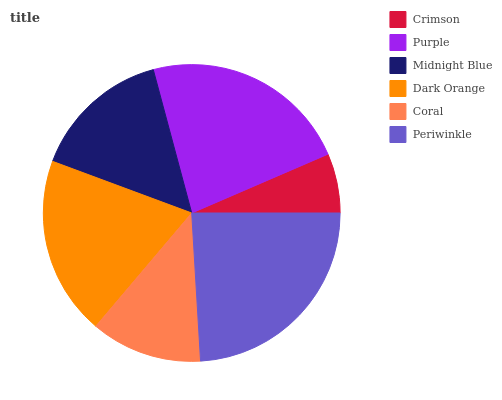Is Crimson the minimum?
Answer yes or no. Yes. Is Periwinkle the maximum?
Answer yes or no. Yes. Is Purple the minimum?
Answer yes or no. No. Is Purple the maximum?
Answer yes or no. No. Is Purple greater than Crimson?
Answer yes or no. Yes. Is Crimson less than Purple?
Answer yes or no. Yes. Is Crimson greater than Purple?
Answer yes or no. No. Is Purple less than Crimson?
Answer yes or no. No. Is Dark Orange the high median?
Answer yes or no. Yes. Is Midnight Blue the low median?
Answer yes or no. Yes. Is Purple the high median?
Answer yes or no. No. Is Periwinkle the low median?
Answer yes or no. No. 